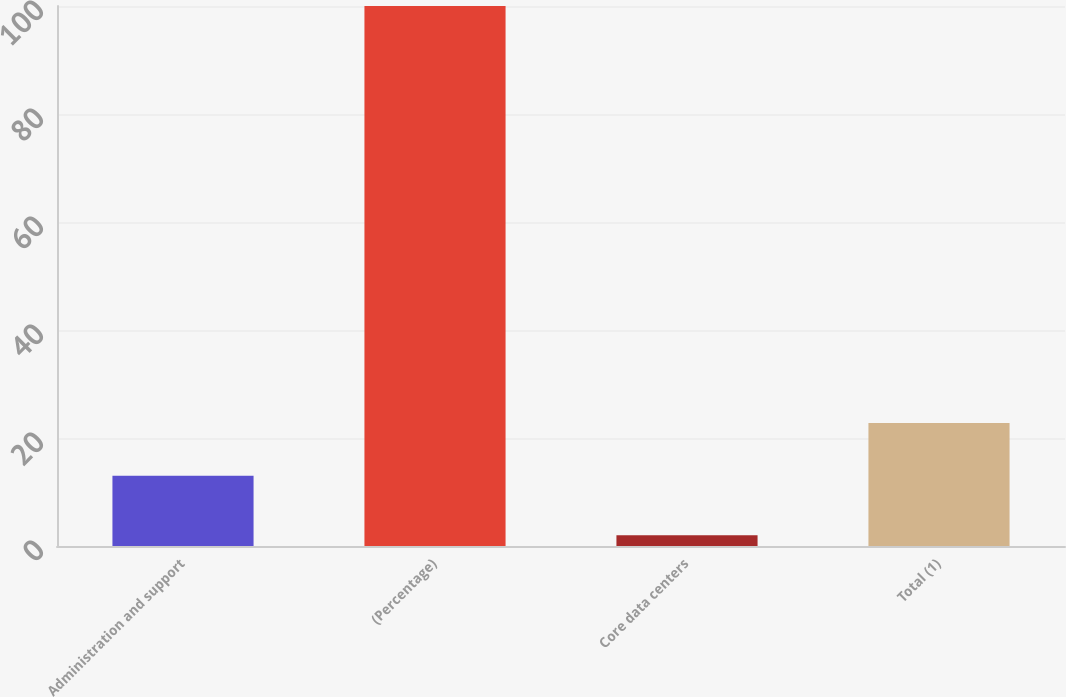<chart> <loc_0><loc_0><loc_500><loc_500><bar_chart><fcel>Administration and support<fcel>(Percentage)<fcel>Core data centers<fcel>Total (1)<nl><fcel>13<fcel>100<fcel>2<fcel>22.8<nl></chart> 